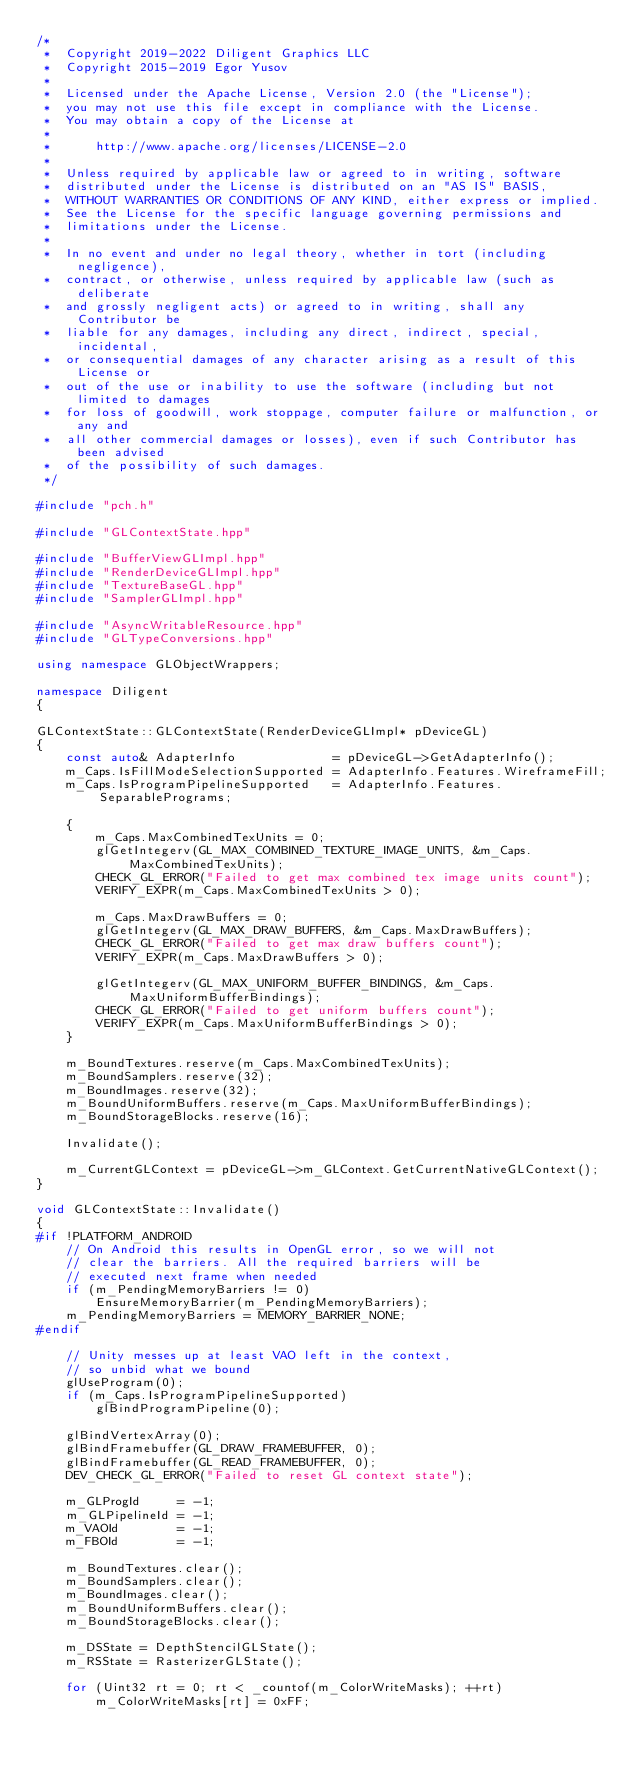Convert code to text. <code><loc_0><loc_0><loc_500><loc_500><_C++_>/*
 *  Copyright 2019-2022 Diligent Graphics LLC
 *  Copyright 2015-2019 Egor Yusov
 *
 *  Licensed under the Apache License, Version 2.0 (the "License");
 *  you may not use this file except in compliance with the License.
 *  You may obtain a copy of the License at
 *
 *      http://www.apache.org/licenses/LICENSE-2.0
 *
 *  Unless required by applicable law or agreed to in writing, software
 *  distributed under the License is distributed on an "AS IS" BASIS,
 *  WITHOUT WARRANTIES OR CONDITIONS OF ANY KIND, either express or implied.
 *  See the License for the specific language governing permissions and
 *  limitations under the License.
 *
 *  In no event and under no legal theory, whether in tort (including negligence),
 *  contract, or otherwise, unless required by applicable law (such as deliberate
 *  and grossly negligent acts) or agreed to in writing, shall any Contributor be
 *  liable for any damages, including any direct, indirect, special, incidental,
 *  or consequential damages of any character arising as a result of this License or
 *  out of the use or inability to use the software (including but not limited to damages
 *  for loss of goodwill, work stoppage, computer failure or malfunction, or any and
 *  all other commercial damages or losses), even if such Contributor has been advised
 *  of the possibility of such damages.
 */

#include "pch.h"

#include "GLContextState.hpp"

#include "BufferViewGLImpl.hpp"
#include "RenderDeviceGLImpl.hpp"
#include "TextureBaseGL.hpp"
#include "SamplerGLImpl.hpp"

#include "AsyncWritableResource.hpp"
#include "GLTypeConversions.hpp"

using namespace GLObjectWrappers;

namespace Diligent
{

GLContextState::GLContextState(RenderDeviceGLImpl* pDeviceGL)
{
    const auto& AdapterInfo             = pDeviceGL->GetAdapterInfo();
    m_Caps.IsFillModeSelectionSupported = AdapterInfo.Features.WireframeFill;
    m_Caps.IsProgramPipelineSupported   = AdapterInfo.Features.SeparablePrograms;

    {
        m_Caps.MaxCombinedTexUnits = 0;
        glGetIntegerv(GL_MAX_COMBINED_TEXTURE_IMAGE_UNITS, &m_Caps.MaxCombinedTexUnits);
        CHECK_GL_ERROR("Failed to get max combined tex image units count");
        VERIFY_EXPR(m_Caps.MaxCombinedTexUnits > 0);

        m_Caps.MaxDrawBuffers = 0;
        glGetIntegerv(GL_MAX_DRAW_BUFFERS, &m_Caps.MaxDrawBuffers);
        CHECK_GL_ERROR("Failed to get max draw buffers count");
        VERIFY_EXPR(m_Caps.MaxDrawBuffers > 0);

        glGetIntegerv(GL_MAX_UNIFORM_BUFFER_BINDINGS, &m_Caps.MaxUniformBufferBindings);
        CHECK_GL_ERROR("Failed to get uniform buffers count");
        VERIFY_EXPR(m_Caps.MaxUniformBufferBindings > 0);
    }

    m_BoundTextures.reserve(m_Caps.MaxCombinedTexUnits);
    m_BoundSamplers.reserve(32);
    m_BoundImages.reserve(32);
    m_BoundUniformBuffers.reserve(m_Caps.MaxUniformBufferBindings);
    m_BoundStorageBlocks.reserve(16);

    Invalidate();

    m_CurrentGLContext = pDeviceGL->m_GLContext.GetCurrentNativeGLContext();
}

void GLContextState::Invalidate()
{
#if !PLATFORM_ANDROID
    // On Android this results in OpenGL error, so we will not
    // clear the barriers. All the required barriers will be
    // executed next frame when needed
    if (m_PendingMemoryBarriers != 0)
        EnsureMemoryBarrier(m_PendingMemoryBarriers);
    m_PendingMemoryBarriers = MEMORY_BARRIER_NONE;
#endif

    // Unity messes up at least VAO left in the context,
    // so unbid what we bound
    glUseProgram(0);
    if (m_Caps.IsProgramPipelineSupported)
        glBindProgramPipeline(0);

    glBindVertexArray(0);
    glBindFramebuffer(GL_DRAW_FRAMEBUFFER, 0);
    glBindFramebuffer(GL_READ_FRAMEBUFFER, 0);
    DEV_CHECK_GL_ERROR("Failed to reset GL context state");

    m_GLProgId     = -1;
    m_GLPipelineId = -1;
    m_VAOId        = -1;
    m_FBOId        = -1;

    m_BoundTextures.clear();
    m_BoundSamplers.clear();
    m_BoundImages.clear();
    m_BoundUniformBuffers.clear();
    m_BoundStorageBlocks.clear();

    m_DSState = DepthStencilGLState();
    m_RSState = RasterizerGLState();

    for (Uint32 rt = 0; rt < _countof(m_ColorWriteMasks); ++rt)
        m_ColorWriteMasks[rt] = 0xFF;
</code> 